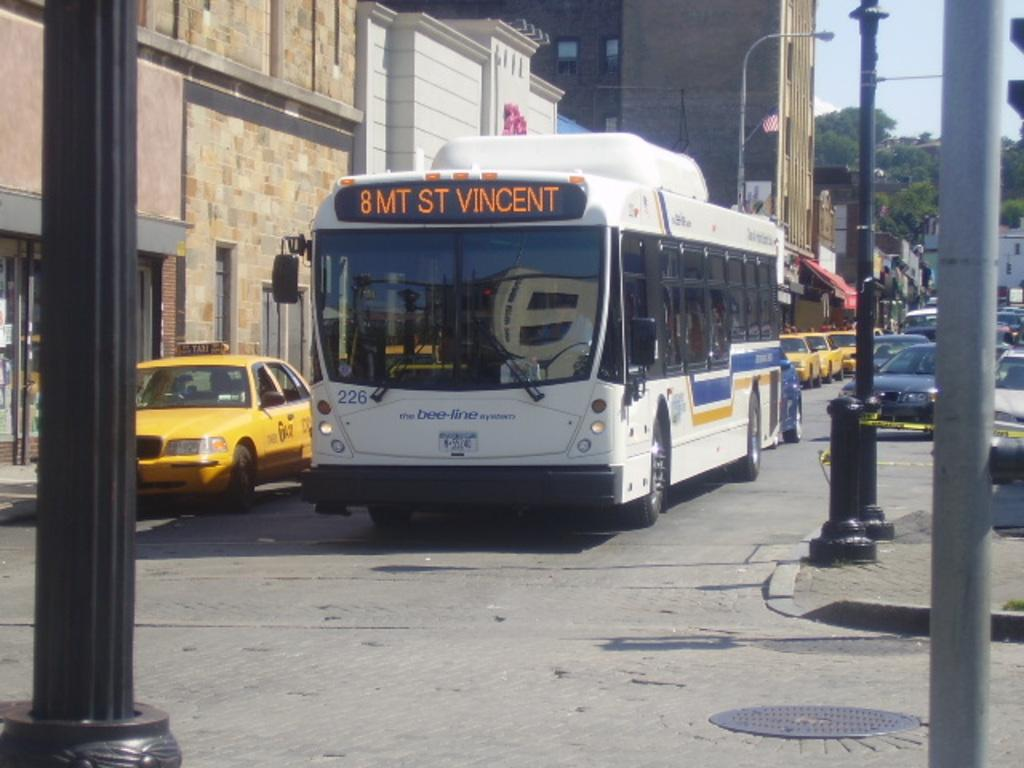<image>
Share a concise interpretation of the image provided. The number 8 bus is stopped next to a taxi. 